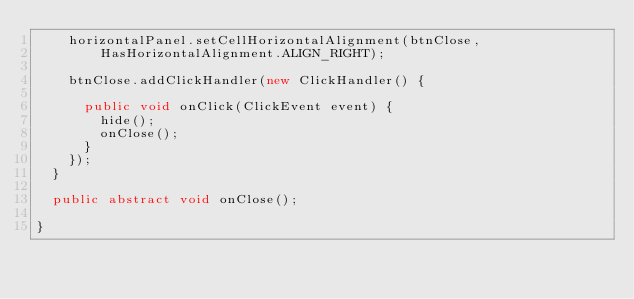Convert code to text. <code><loc_0><loc_0><loc_500><loc_500><_Java_>		horizontalPanel.setCellHorizontalAlignment(btnClose,
				HasHorizontalAlignment.ALIGN_RIGHT);

		btnClose.addClickHandler(new ClickHandler() {

			public void onClick(ClickEvent event) {
				hide();
				onClose();
			}
		});
	}

	public abstract void onClose();

}
</code> 